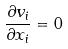Convert formula to latex. <formula><loc_0><loc_0><loc_500><loc_500>\frac { \partial v _ { i } } { \partial x _ { i } } = 0</formula> 